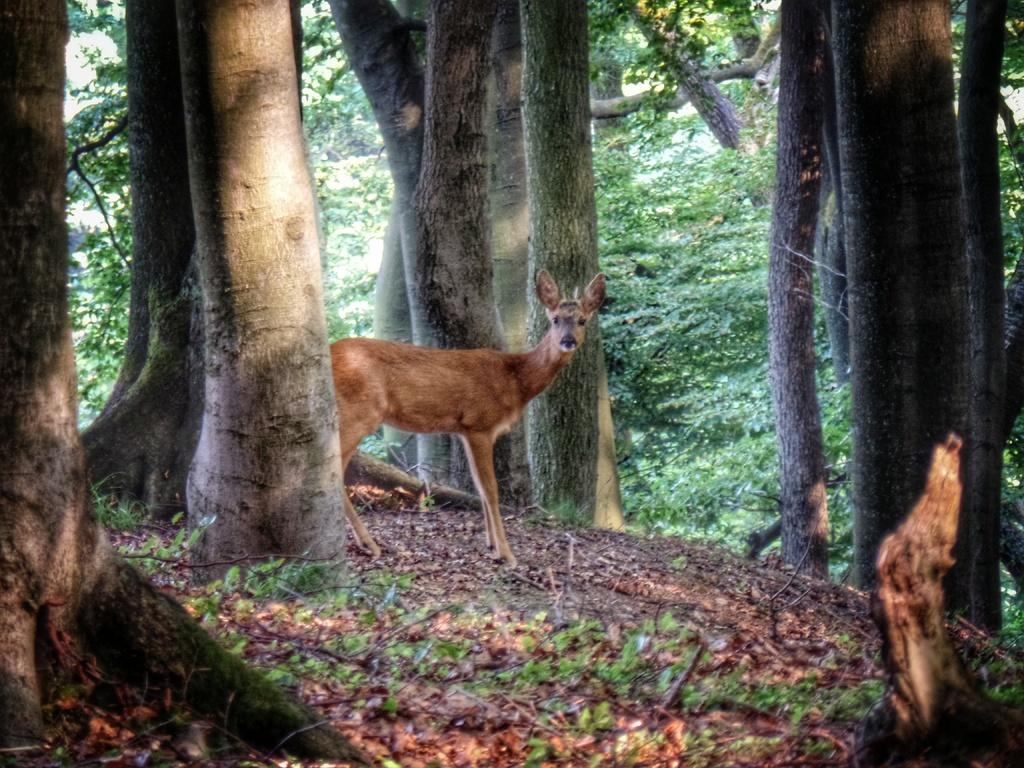What animal can be seen in the image? There is a deer in the image. What is the deer's position in the image? The deer is standing on the ground. What can be seen in the background of the image? There is a group of trees in the background of the image. What type of muscle is being exercised by the deer in the image? There is no indication in the image that the deer is exercising any muscles, as it is simply standing on the ground. 